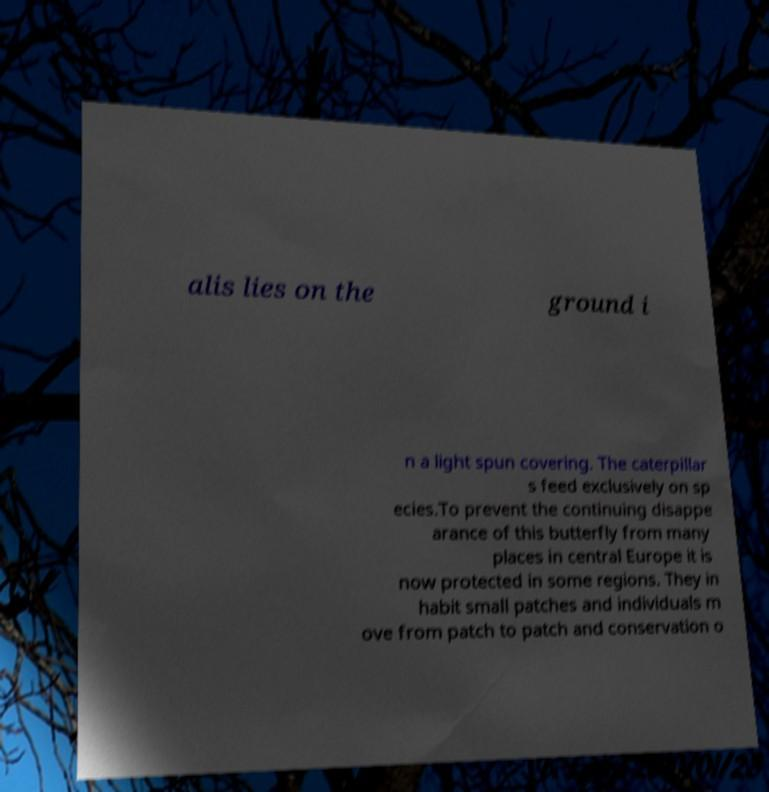Could you assist in decoding the text presented in this image and type it out clearly? alis lies on the ground i n a light spun covering. The caterpillar s feed exclusively on sp ecies.To prevent the continuing disappe arance of this butterfly from many places in central Europe it is now protected in some regions. They in habit small patches and individuals m ove from patch to patch and conservation o 